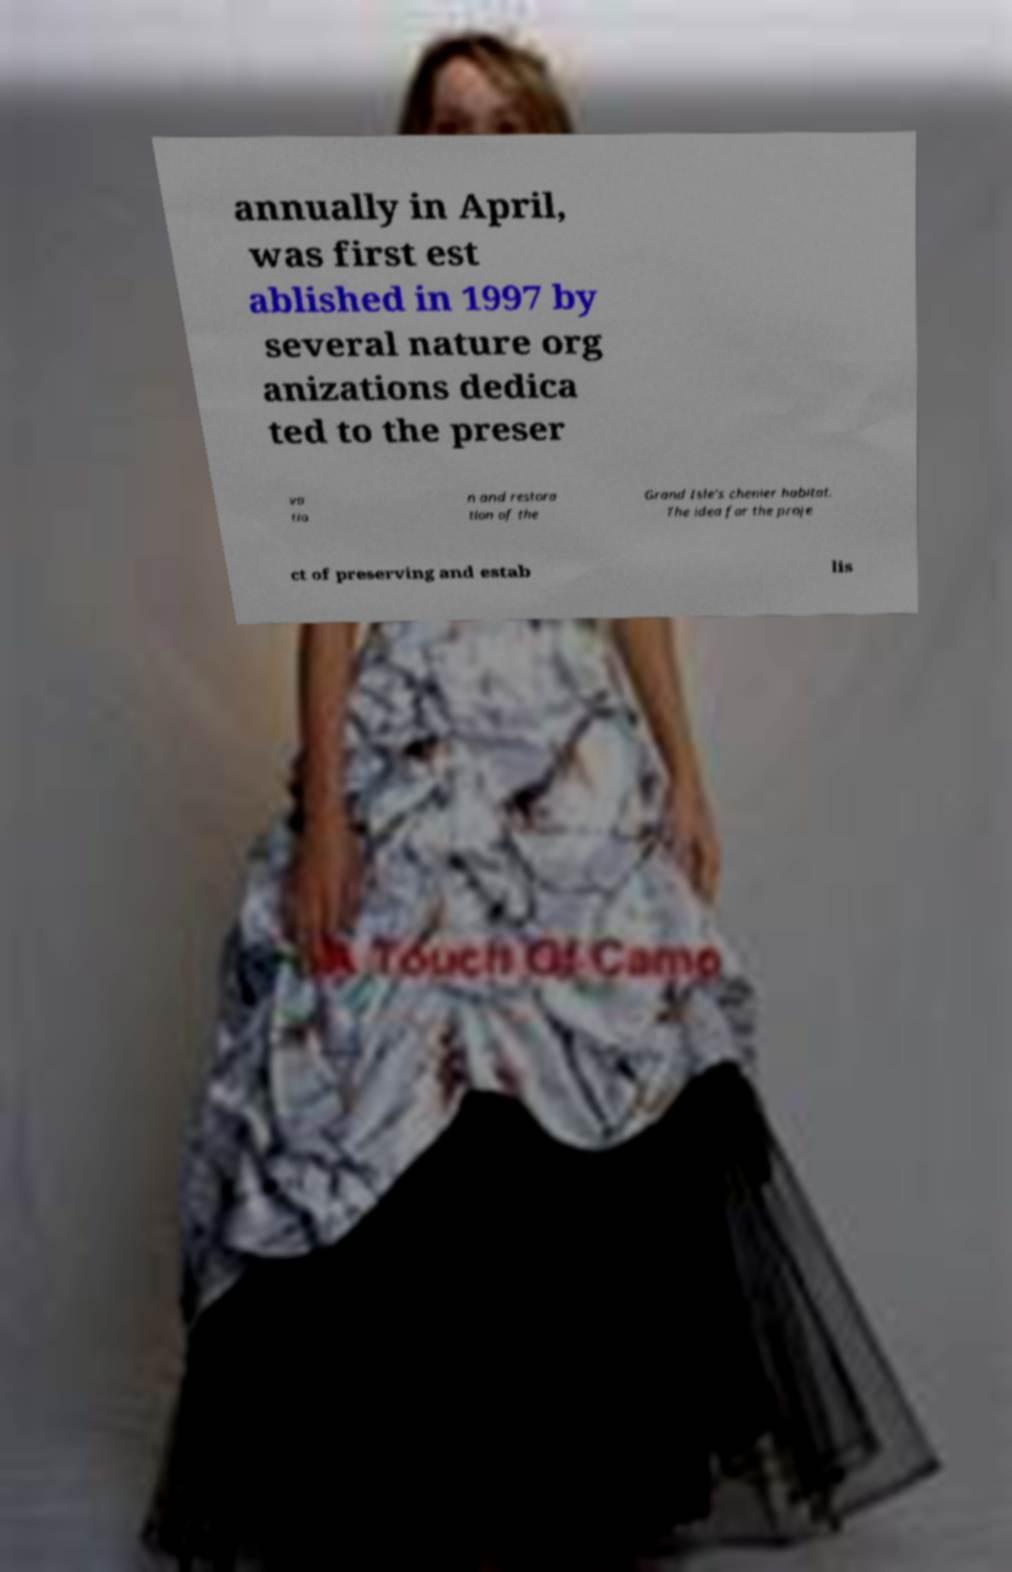For documentation purposes, I need the text within this image transcribed. Could you provide that? annually in April, was first est ablished in 1997 by several nature org anizations dedica ted to the preser va tio n and restora tion of the Grand Isle's chenier habitat. The idea for the proje ct of preserving and estab lis 